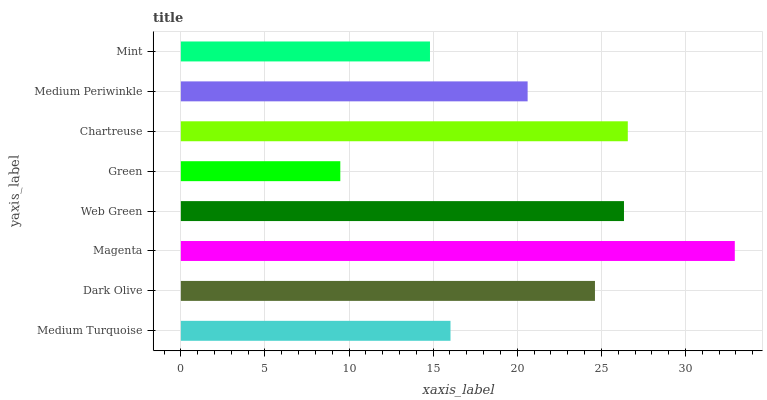Is Green the minimum?
Answer yes or no. Yes. Is Magenta the maximum?
Answer yes or no. Yes. Is Dark Olive the minimum?
Answer yes or no. No. Is Dark Olive the maximum?
Answer yes or no. No. Is Dark Olive greater than Medium Turquoise?
Answer yes or no. Yes. Is Medium Turquoise less than Dark Olive?
Answer yes or no. Yes. Is Medium Turquoise greater than Dark Olive?
Answer yes or no. No. Is Dark Olive less than Medium Turquoise?
Answer yes or no. No. Is Dark Olive the high median?
Answer yes or no. Yes. Is Medium Periwinkle the low median?
Answer yes or no. Yes. Is Medium Periwinkle the high median?
Answer yes or no. No. Is Chartreuse the low median?
Answer yes or no. No. 